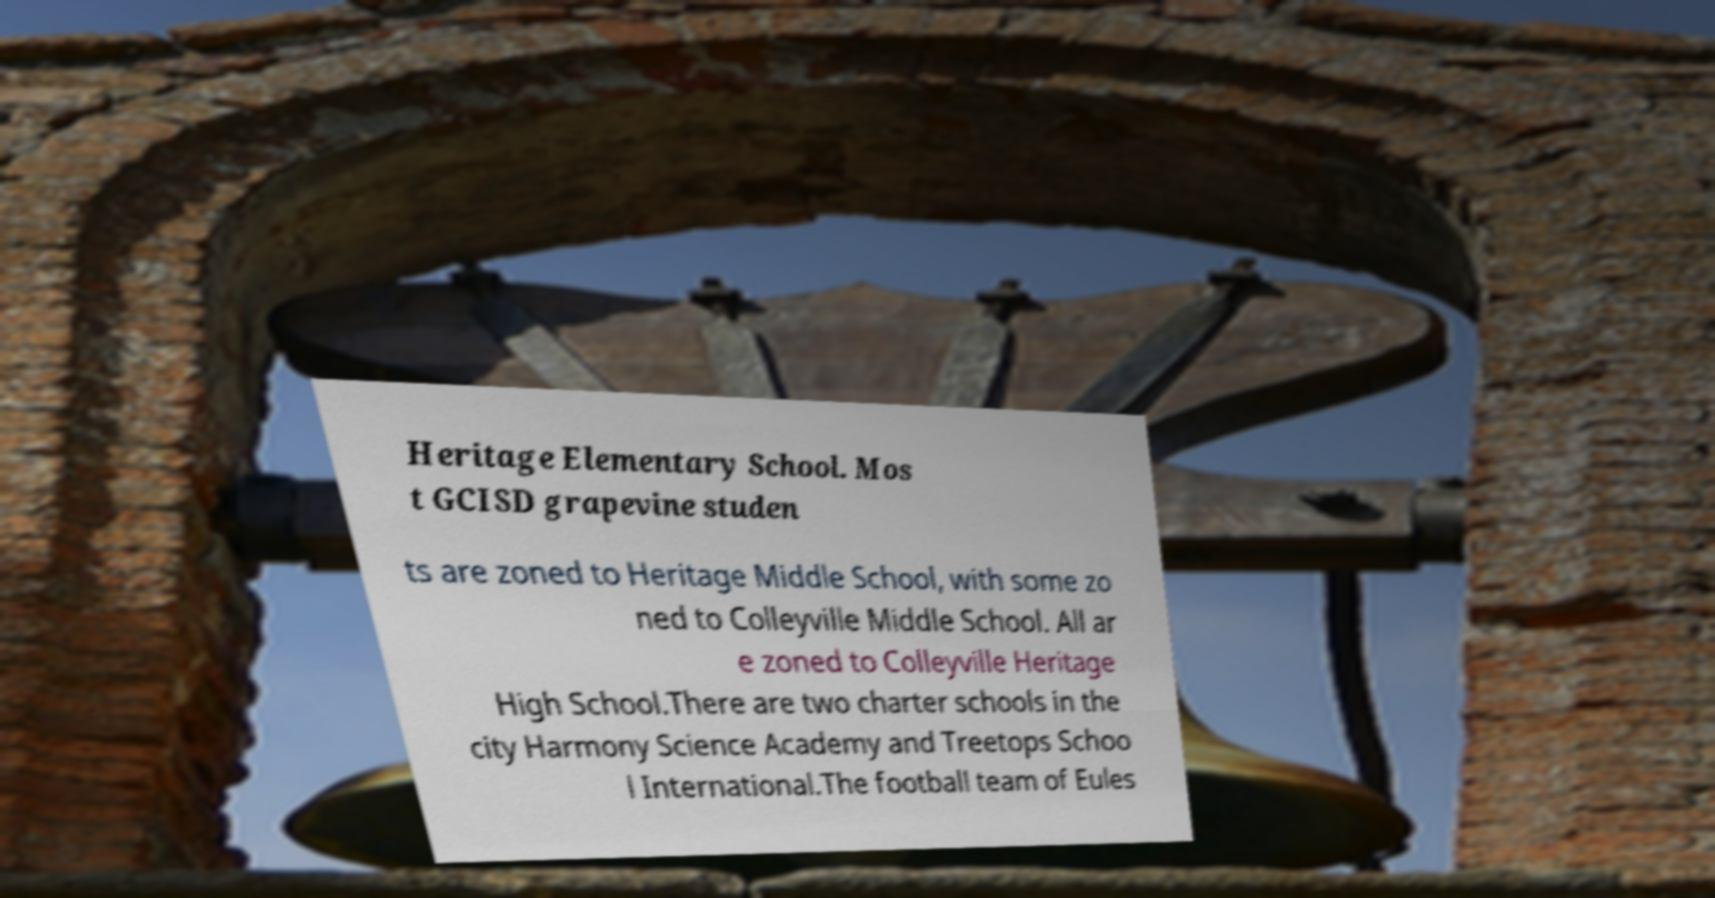Could you extract and type out the text from this image? Heritage Elementary School. Mos t GCISD grapevine studen ts are zoned to Heritage Middle School, with some zo ned to Colleyville Middle School. All ar e zoned to Colleyville Heritage High School.There are two charter schools in the city Harmony Science Academy and Treetops Schoo l International.The football team of Eules 